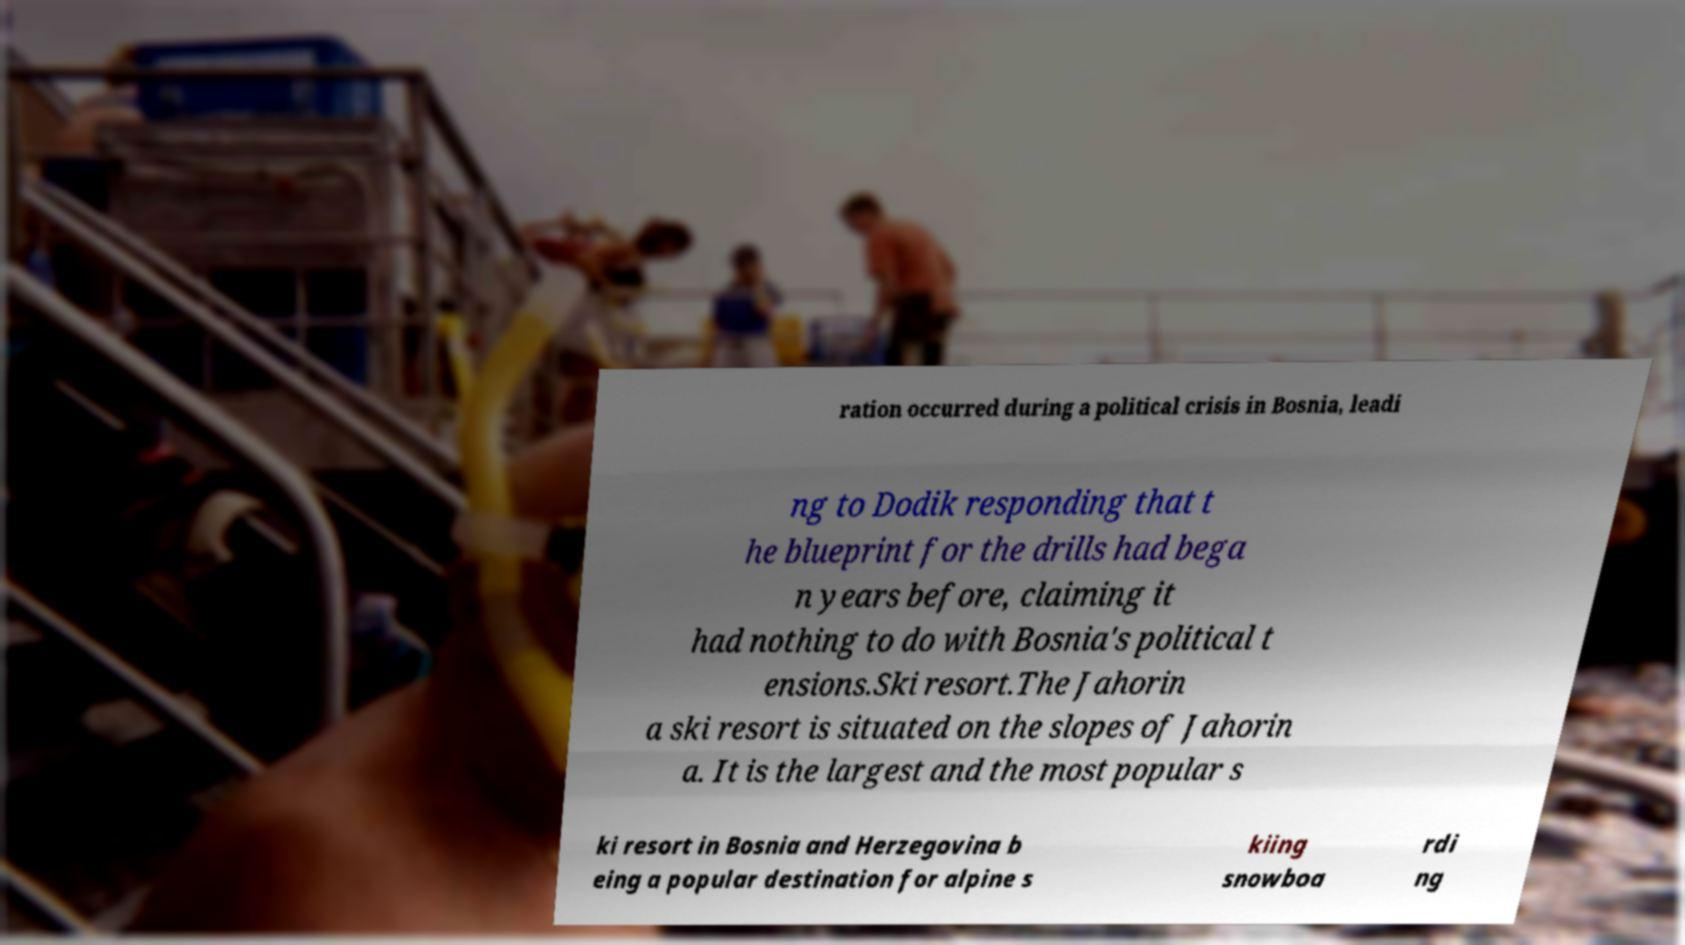Could you assist in decoding the text presented in this image and type it out clearly? ration occurred during a political crisis in Bosnia, leadi ng to Dodik responding that t he blueprint for the drills had bega n years before, claiming it had nothing to do with Bosnia's political t ensions.Ski resort.The Jahorin a ski resort is situated on the slopes of Jahorin a. It is the largest and the most popular s ki resort in Bosnia and Herzegovina b eing a popular destination for alpine s kiing snowboa rdi ng 